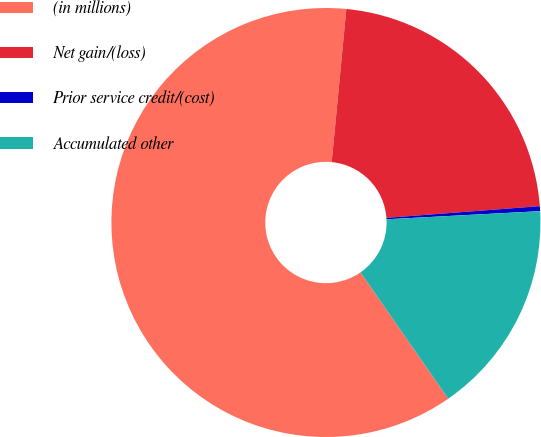<chart> <loc_0><loc_0><loc_500><loc_500><pie_chart><fcel>(in millions)<fcel>Net gain/(loss)<fcel>Prior service credit/(cost)<fcel>Accumulated other<nl><fcel>61.18%<fcel>22.27%<fcel>0.37%<fcel>16.19%<nl></chart> 